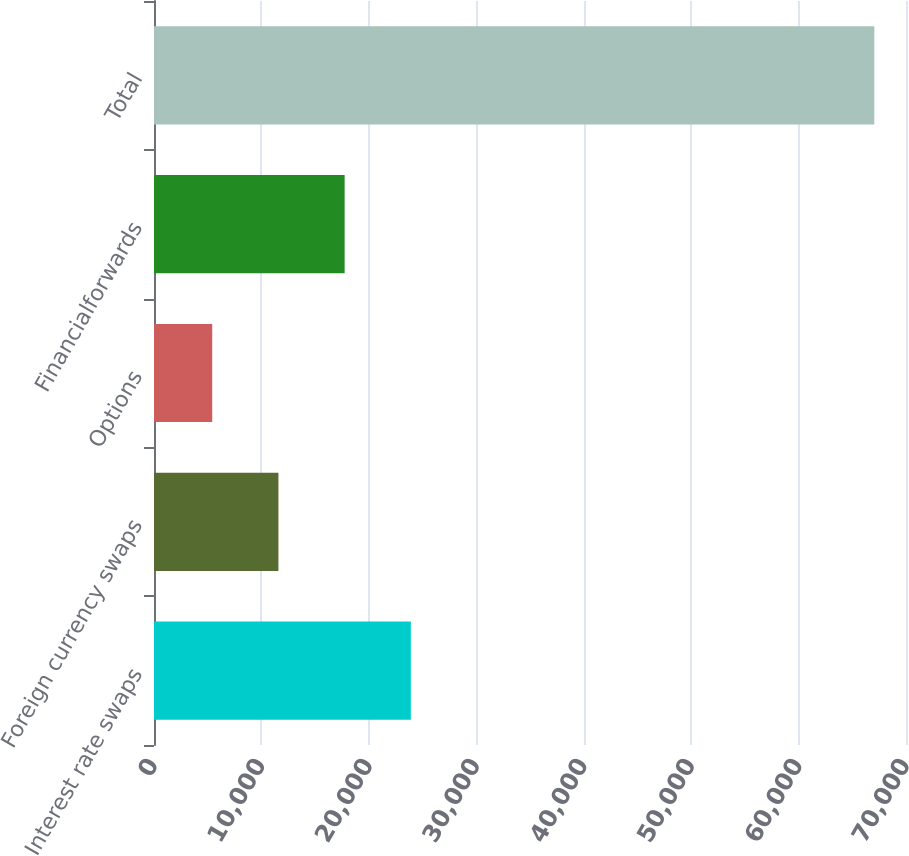Convert chart to OTSL. <chart><loc_0><loc_0><loc_500><loc_500><bar_chart><fcel>Interest rate swaps<fcel>Foreign currency swaps<fcel>Options<fcel>Financialforwards<fcel>Total<nl><fcel>23908<fcel>11582<fcel>5419<fcel>17745<fcel>67049<nl></chart> 